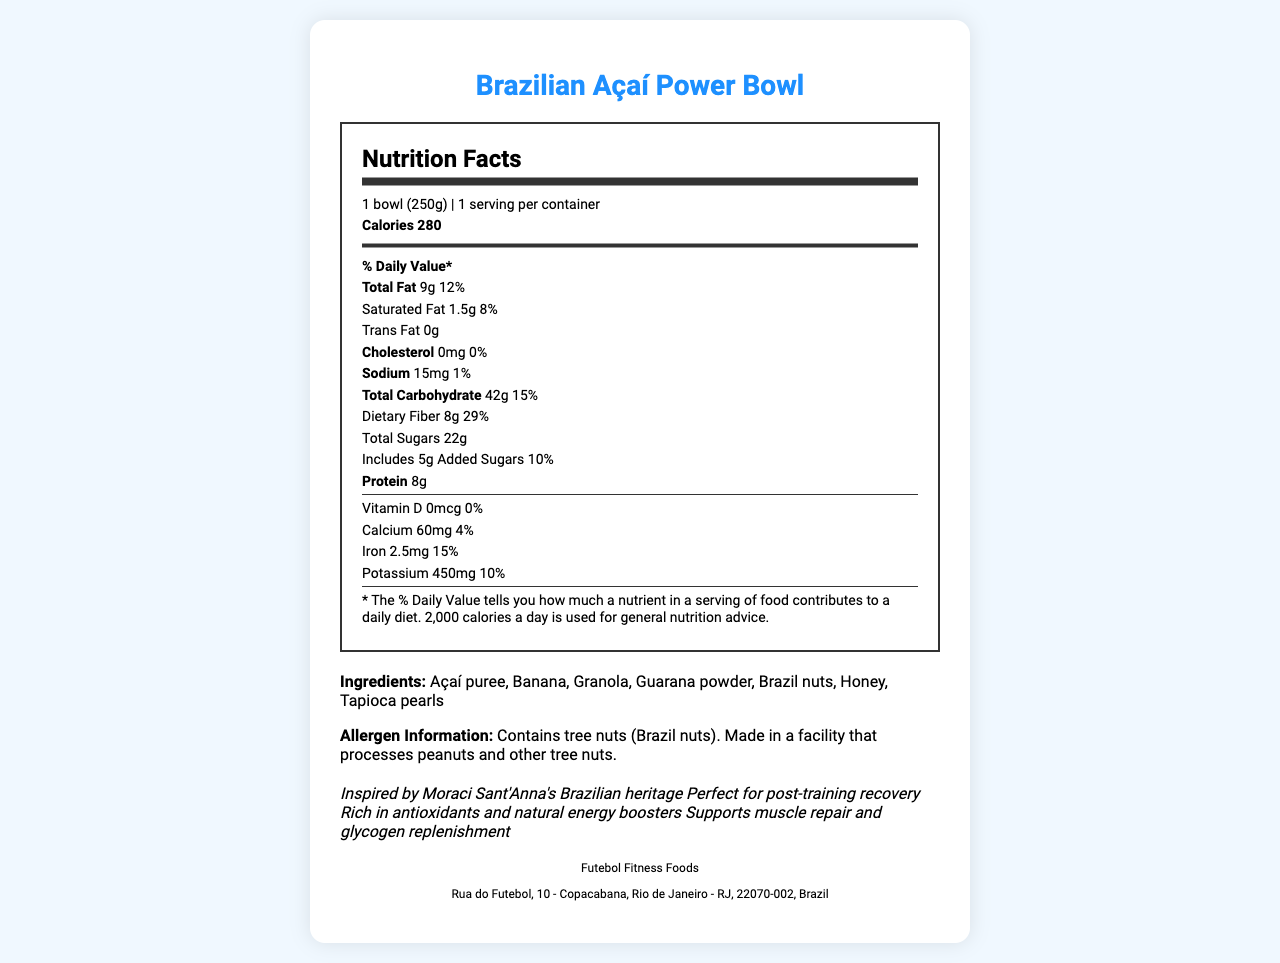what is the serving size of the Brazilian Açaí Power Bowl? The serving size is listed as "1 bowl (250g)" in the document.
Answer: 1 bowl (250g) how many calories does one serving of the Brazilian Açaí Power Bowl contain? The document states that one serving contains 280 calories.
Answer: 280 What is the amount of protein in the Brazilian Açaí Power Bowl? The document lists the protein content as 8 grams.
Answer: 8g What is the percentage of the daily value for Dietary Fiber in the Brazilian Açaí Power Bowl? The document specifies that the dietary fiber contributes 29% of the daily value.
Answer: 29% Does the Brazilian Açaí Power Bowl contain any trans fat? The document states "Trans Fat 0g".
Answer: No What are the main ingredients in the Brazilian Açaí Power Bowl? These ingredients are listed under the section labeled "Ingredients".
Answer: Açaí puree, Banana, Granola, Guarana powder, Brazil nuts, Honey, Tapioca pearls contains tree nuts? A. Yes B. No The allergen information in the document indicates that it contains tree nuts (Brazil nuts).
Answer: A. Yes How much potassium does a serving of the Brazilian Açaí Power Bowl provide? A. 200mg B. 350mg C. 450mg D. 500mg The document states that one serving provides 450mg of potassium.
Answer: C. 450mg Is the Brazilian Açaí Power Bowl suitable for someone with a peanut allergy? The document notes it is made in a facility that processes peanuts.
Answer: No What is the percentage of daily value for calcium in the Brazilian Açaí Power Bowl? The document lists the calcium daily value percentage as 4%.
Answer: 4% What Brazilian native ingredient is found in the Brazilian Açaí Power Bowl? Açaí is native to Brazil and is listed as an ingredient.
Answer: Açaí puree Summarize the key nutritional benefits of the Brazilian Açaí Power Bowl. This summary captures the additional information provided about the benefits of the snack.
Answer: Rich in antioxidants, natural energy boosters, and supports muscle repair and glycogen replenishment, suitable for post-training recovery. Where is the manufacturer of the Brazilian Açaí Power Bowl located? The manufacturer information section provides this address.
Answer: Rua do Futebol, 10 - Copacabana, Rio de Janeiro - RJ, 22070-002, Brazil Which nutrient is not present in the Brazilian Açaí Power Bowl? The document states there is 0mcg of Vitamin D, providing 0% of the daily value.
Answer: Vitamin D Is this product inspired by Moraci Sant'Anna's Brazilian heritage? The additional info states that the product is Inspired by Moraci Sant'Anna's Brazilian heritage.
Answer: Yes Who is the manufacturer of the Brazilian Açaí Power Bowl? This information is listed under the manufacturer info section.
Answer: Futebol Fitness Foods How much-saturated fat does a serving of the Brazilian Açaí Power Bowl contain? The document lists the saturated fat content as 1.5 grams.
Answer: 1.5g Does the Brazilian Açaí Power Bowl include added sugars? The document indicates that it includes 5g of added sugars.
Answer: Yes What is the total carbohydrate content in one serving? The document lists the total carbohydrate content as 42 grams.
Answer: 42g How is this product recommended for use? The additional info mentions it is perfect for post-training recovery.
Answer: Perfect for post-training recovery What are the nutritional benefits promoted in the additional info? A. Rich in antioxidants B. Supports muscle repair C. Natural energy boosters D. All of the above The additional info lists "Rich in antioxidants", "Supports muscle repair", and "Natural energy boosters".
Answer: D. All of the above What are tapioca pearls? The document lists tapioca pearls as an ingredient but does not provide a description or detail about what they are.
Answer: Cannot be determined 